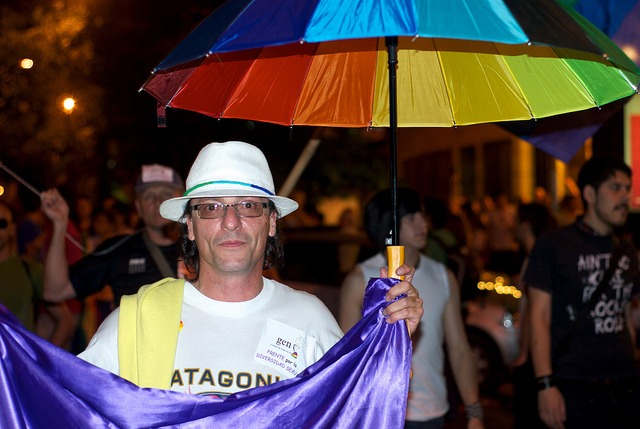Can you describe the person's attire and accessories? Certainly! The person is wearing a white broad-brimmed hat with a colored band, clear eyeglasses, and a white t-shirt with a logo on it. They're also holding a large rainbow-colored umbrella and are draped in a flowing purple cloth, adding to the vibrancy of their appearance. These items together create a festive look that may align with a celebratory theme. 